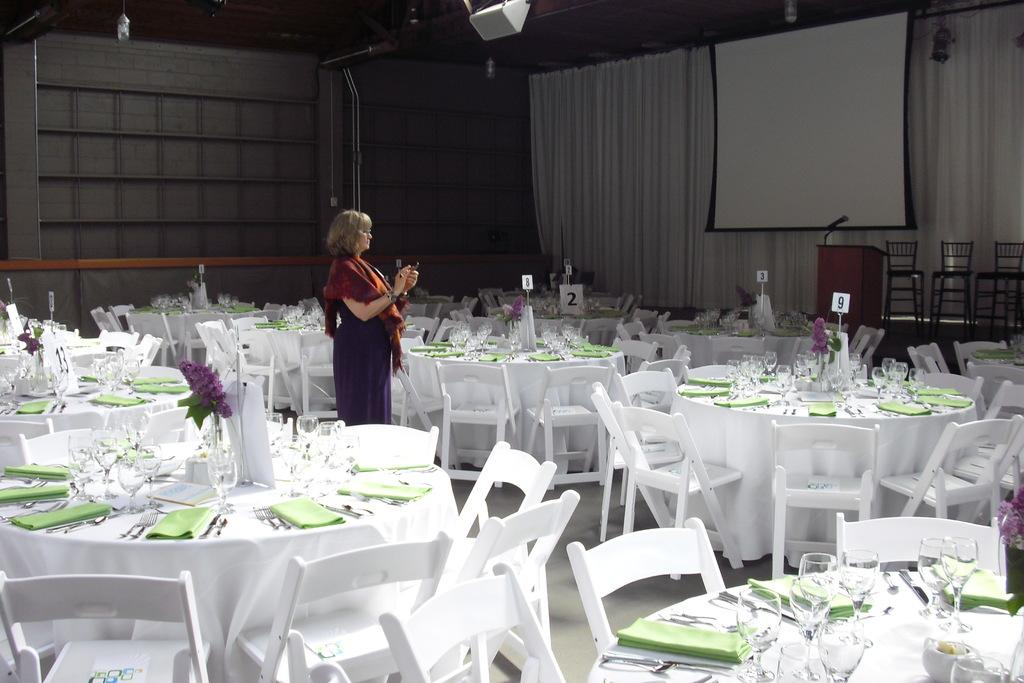Who is the main subject in the image? There is a woman standing in the middle of the image. What type of furniture is present in the room? There are tables and chairs in the room. What can be seen on the right side of the image? There is a curtain on the right side of the image. What type of discovery is being made by the fairies in the image? There are no fairies present in the image, so no discovery can be observed. 